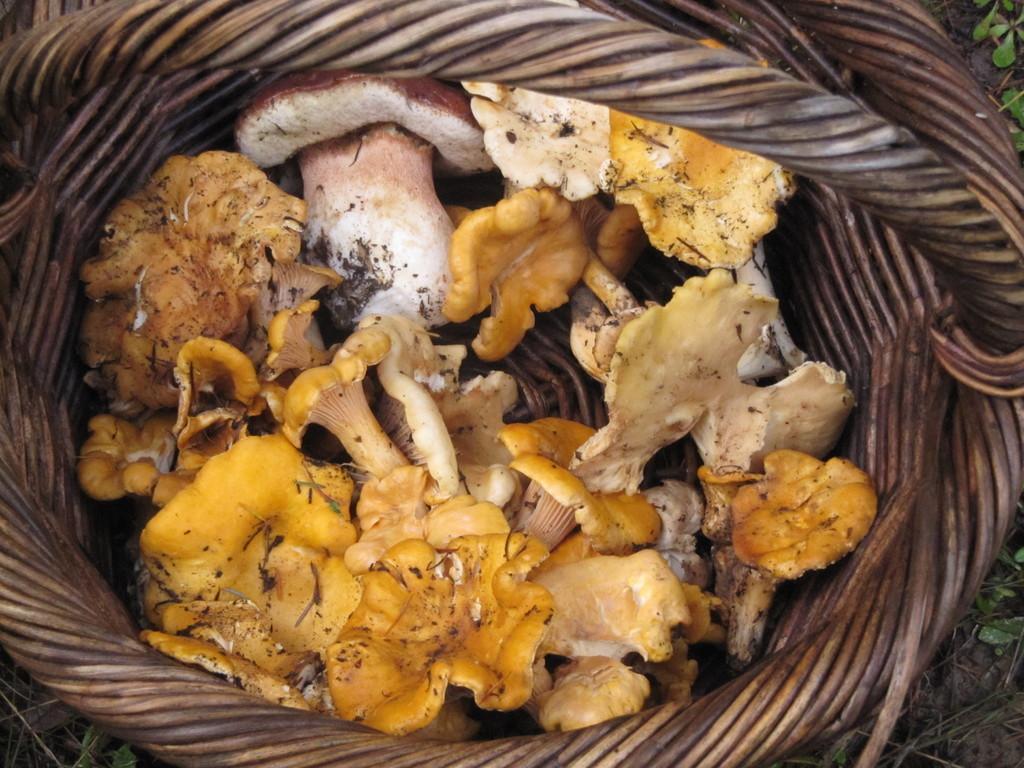How would you summarize this image in a sentence or two? In this image we can see mushrooms placed in a basket. 